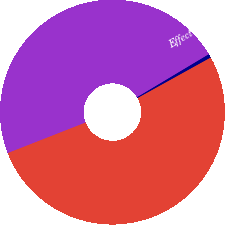Convert chart. <chart><loc_0><loc_0><loc_500><loc_500><pie_chart><fcel>Net debt to net capital<fcel>Effect of subtracting cash<fcel>Debt to capital<nl><fcel>47.36%<fcel>0.54%<fcel>52.1%<nl></chart> 